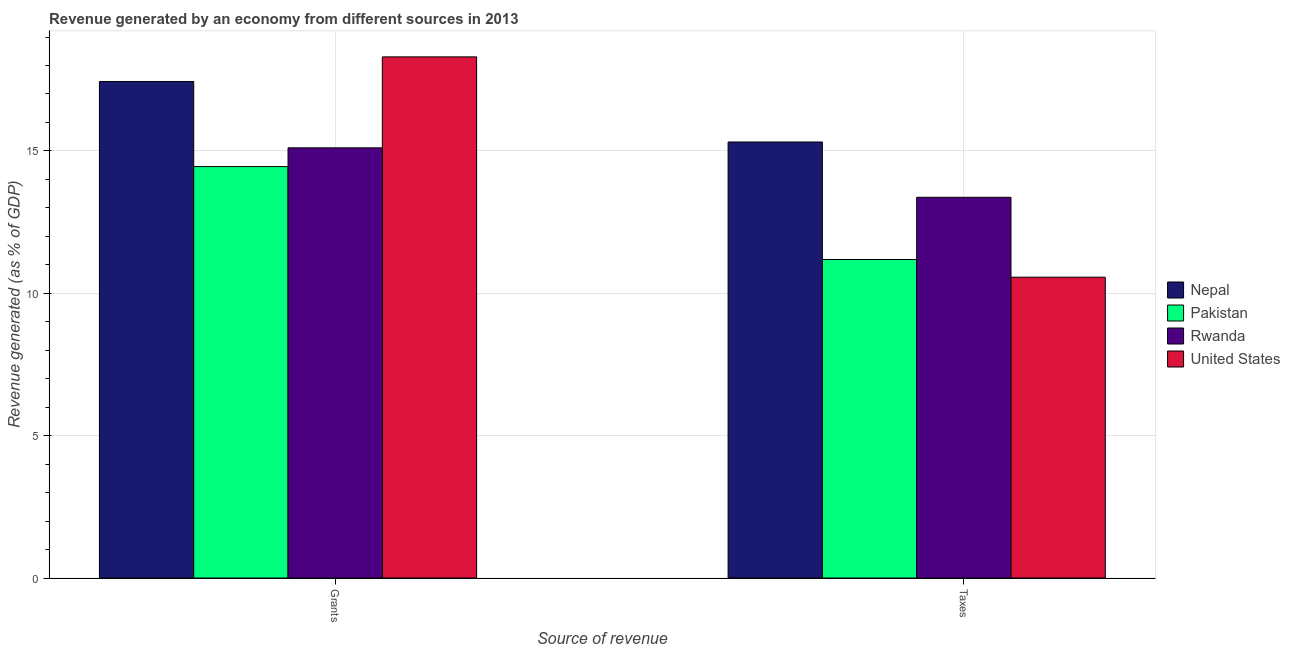How many different coloured bars are there?
Make the answer very short. 4. How many groups of bars are there?
Ensure brevity in your answer.  2. Are the number of bars per tick equal to the number of legend labels?
Provide a short and direct response. Yes. How many bars are there on the 2nd tick from the right?
Ensure brevity in your answer.  4. What is the label of the 1st group of bars from the left?
Your response must be concise. Grants. What is the revenue generated by taxes in United States?
Provide a succinct answer. 10.57. Across all countries, what is the maximum revenue generated by grants?
Give a very brief answer. 18.3. Across all countries, what is the minimum revenue generated by taxes?
Your response must be concise. 10.57. In which country was the revenue generated by taxes maximum?
Your answer should be compact. Nepal. In which country was the revenue generated by grants minimum?
Give a very brief answer. Pakistan. What is the total revenue generated by taxes in the graph?
Give a very brief answer. 50.44. What is the difference between the revenue generated by taxes in Pakistan and that in Nepal?
Offer a terse response. -4.13. What is the difference between the revenue generated by grants in Nepal and the revenue generated by taxes in Pakistan?
Your answer should be compact. 6.25. What is the average revenue generated by taxes per country?
Provide a short and direct response. 12.61. What is the difference between the revenue generated by taxes and revenue generated by grants in Nepal?
Ensure brevity in your answer.  -2.13. In how many countries, is the revenue generated by grants greater than 2 %?
Offer a very short reply. 4. What is the ratio of the revenue generated by taxes in Nepal to that in United States?
Your answer should be very brief. 1.45. Is the revenue generated by taxes in United States less than that in Nepal?
Offer a very short reply. Yes. How many bars are there?
Your answer should be very brief. 8. Are all the bars in the graph horizontal?
Ensure brevity in your answer.  No. How many countries are there in the graph?
Ensure brevity in your answer.  4. What is the difference between two consecutive major ticks on the Y-axis?
Your answer should be compact. 5. Does the graph contain grids?
Give a very brief answer. Yes. Where does the legend appear in the graph?
Your answer should be very brief. Center right. How many legend labels are there?
Your response must be concise. 4. What is the title of the graph?
Provide a short and direct response. Revenue generated by an economy from different sources in 2013. Does "Namibia" appear as one of the legend labels in the graph?
Your response must be concise. No. What is the label or title of the X-axis?
Your response must be concise. Source of revenue. What is the label or title of the Y-axis?
Your answer should be compact. Revenue generated (as % of GDP). What is the Revenue generated (as % of GDP) in Nepal in Grants?
Make the answer very short. 17.44. What is the Revenue generated (as % of GDP) of Pakistan in Grants?
Offer a very short reply. 14.45. What is the Revenue generated (as % of GDP) of Rwanda in Grants?
Your answer should be very brief. 15.11. What is the Revenue generated (as % of GDP) of United States in Grants?
Offer a very short reply. 18.3. What is the Revenue generated (as % of GDP) in Nepal in Taxes?
Your answer should be very brief. 15.31. What is the Revenue generated (as % of GDP) of Pakistan in Taxes?
Your answer should be compact. 11.19. What is the Revenue generated (as % of GDP) in Rwanda in Taxes?
Your answer should be very brief. 13.37. What is the Revenue generated (as % of GDP) of United States in Taxes?
Provide a succinct answer. 10.57. Across all Source of revenue, what is the maximum Revenue generated (as % of GDP) of Nepal?
Give a very brief answer. 17.44. Across all Source of revenue, what is the maximum Revenue generated (as % of GDP) of Pakistan?
Make the answer very short. 14.45. Across all Source of revenue, what is the maximum Revenue generated (as % of GDP) of Rwanda?
Your response must be concise. 15.11. Across all Source of revenue, what is the maximum Revenue generated (as % of GDP) of United States?
Offer a very short reply. 18.3. Across all Source of revenue, what is the minimum Revenue generated (as % of GDP) of Nepal?
Your answer should be very brief. 15.31. Across all Source of revenue, what is the minimum Revenue generated (as % of GDP) in Pakistan?
Ensure brevity in your answer.  11.19. Across all Source of revenue, what is the minimum Revenue generated (as % of GDP) in Rwanda?
Your answer should be very brief. 13.37. Across all Source of revenue, what is the minimum Revenue generated (as % of GDP) in United States?
Provide a short and direct response. 10.57. What is the total Revenue generated (as % of GDP) of Nepal in the graph?
Offer a terse response. 32.75. What is the total Revenue generated (as % of GDP) in Pakistan in the graph?
Your response must be concise. 25.64. What is the total Revenue generated (as % of GDP) in Rwanda in the graph?
Offer a terse response. 28.48. What is the total Revenue generated (as % of GDP) of United States in the graph?
Give a very brief answer. 28.87. What is the difference between the Revenue generated (as % of GDP) of Nepal in Grants and that in Taxes?
Offer a very short reply. 2.13. What is the difference between the Revenue generated (as % of GDP) in Pakistan in Grants and that in Taxes?
Your answer should be compact. 3.26. What is the difference between the Revenue generated (as % of GDP) of Rwanda in Grants and that in Taxes?
Provide a short and direct response. 1.74. What is the difference between the Revenue generated (as % of GDP) in United States in Grants and that in Taxes?
Offer a very short reply. 7.74. What is the difference between the Revenue generated (as % of GDP) of Nepal in Grants and the Revenue generated (as % of GDP) of Pakistan in Taxes?
Offer a terse response. 6.25. What is the difference between the Revenue generated (as % of GDP) of Nepal in Grants and the Revenue generated (as % of GDP) of Rwanda in Taxes?
Ensure brevity in your answer.  4.07. What is the difference between the Revenue generated (as % of GDP) in Nepal in Grants and the Revenue generated (as % of GDP) in United States in Taxes?
Provide a succinct answer. 6.87. What is the difference between the Revenue generated (as % of GDP) of Pakistan in Grants and the Revenue generated (as % of GDP) of Rwanda in Taxes?
Keep it short and to the point. 1.08. What is the difference between the Revenue generated (as % of GDP) in Pakistan in Grants and the Revenue generated (as % of GDP) in United States in Taxes?
Ensure brevity in your answer.  3.88. What is the difference between the Revenue generated (as % of GDP) in Rwanda in Grants and the Revenue generated (as % of GDP) in United States in Taxes?
Your answer should be compact. 4.54. What is the average Revenue generated (as % of GDP) of Nepal per Source of revenue?
Keep it short and to the point. 16.38. What is the average Revenue generated (as % of GDP) in Pakistan per Source of revenue?
Provide a short and direct response. 12.82. What is the average Revenue generated (as % of GDP) in Rwanda per Source of revenue?
Provide a succinct answer. 14.24. What is the average Revenue generated (as % of GDP) of United States per Source of revenue?
Give a very brief answer. 14.43. What is the difference between the Revenue generated (as % of GDP) of Nepal and Revenue generated (as % of GDP) of Pakistan in Grants?
Keep it short and to the point. 2.99. What is the difference between the Revenue generated (as % of GDP) of Nepal and Revenue generated (as % of GDP) of Rwanda in Grants?
Offer a very short reply. 2.33. What is the difference between the Revenue generated (as % of GDP) in Nepal and Revenue generated (as % of GDP) in United States in Grants?
Make the answer very short. -0.86. What is the difference between the Revenue generated (as % of GDP) of Pakistan and Revenue generated (as % of GDP) of Rwanda in Grants?
Make the answer very short. -0.66. What is the difference between the Revenue generated (as % of GDP) of Pakistan and Revenue generated (as % of GDP) of United States in Grants?
Make the answer very short. -3.85. What is the difference between the Revenue generated (as % of GDP) in Rwanda and Revenue generated (as % of GDP) in United States in Grants?
Make the answer very short. -3.19. What is the difference between the Revenue generated (as % of GDP) of Nepal and Revenue generated (as % of GDP) of Pakistan in Taxes?
Keep it short and to the point. 4.13. What is the difference between the Revenue generated (as % of GDP) of Nepal and Revenue generated (as % of GDP) of Rwanda in Taxes?
Offer a terse response. 1.94. What is the difference between the Revenue generated (as % of GDP) in Nepal and Revenue generated (as % of GDP) in United States in Taxes?
Your answer should be compact. 4.75. What is the difference between the Revenue generated (as % of GDP) in Pakistan and Revenue generated (as % of GDP) in Rwanda in Taxes?
Provide a succinct answer. -2.18. What is the difference between the Revenue generated (as % of GDP) of Pakistan and Revenue generated (as % of GDP) of United States in Taxes?
Offer a terse response. 0.62. What is the difference between the Revenue generated (as % of GDP) of Rwanda and Revenue generated (as % of GDP) of United States in Taxes?
Provide a short and direct response. 2.81. What is the ratio of the Revenue generated (as % of GDP) in Nepal in Grants to that in Taxes?
Give a very brief answer. 1.14. What is the ratio of the Revenue generated (as % of GDP) in Pakistan in Grants to that in Taxes?
Your answer should be compact. 1.29. What is the ratio of the Revenue generated (as % of GDP) in Rwanda in Grants to that in Taxes?
Your answer should be compact. 1.13. What is the ratio of the Revenue generated (as % of GDP) in United States in Grants to that in Taxes?
Offer a terse response. 1.73. What is the difference between the highest and the second highest Revenue generated (as % of GDP) in Nepal?
Keep it short and to the point. 2.13. What is the difference between the highest and the second highest Revenue generated (as % of GDP) in Pakistan?
Keep it short and to the point. 3.26. What is the difference between the highest and the second highest Revenue generated (as % of GDP) in Rwanda?
Make the answer very short. 1.74. What is the difference between the highest and the second highest Revenue generated (as % of GDP) of United States?
Offer a very short reply. 7.74. What is the difference between the highest and the lowest Revenue generated (as % of GDP) in Nepal?
Your answer should be compact. 2.13. What is the difference between the highest and the lowest Revenue generated (as % of GDP) of Pakistan?
Provide a short and direct response. 3.26. What is the difference between the highest and the lowest Revenue generated (as % of GDP) of Rwanda?
Your answer should be compact. 1.74. What is the difference between the highest and the lowest Revenue generated (as % of GDP) in United States?
Offer a very short reply. 7.74. 